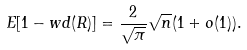Convert formula to latex. <formula><loc_0><loc_0><loc_500><loc_500>E [ 1 - w d ( R ) ] = \frac { 2 } { \sqrt { \pi } } \sqrt { n } ( 1 + o ( 1 ) ) .</formula> 